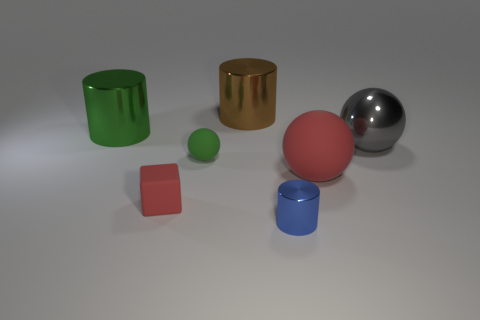Subtract all matte spheres. How many spheres are left? 1 Add 1 big spheres. How many objects exist? 8 Subtract all cylinders. How many objects are left? 4 Add 7 blue shiny things. How many blue shiny things are left? 8 Add 4 big things. How many big things exist? 8 Subtract 0 brown cubes. How many objects are left? 7 Subtract all purple balls. Subtract all brown cylinders. How many balls are left? 3 Subtract all big brown shiny cylinders. Subtract all tiny rubber spheres. How many objects are left? 5 